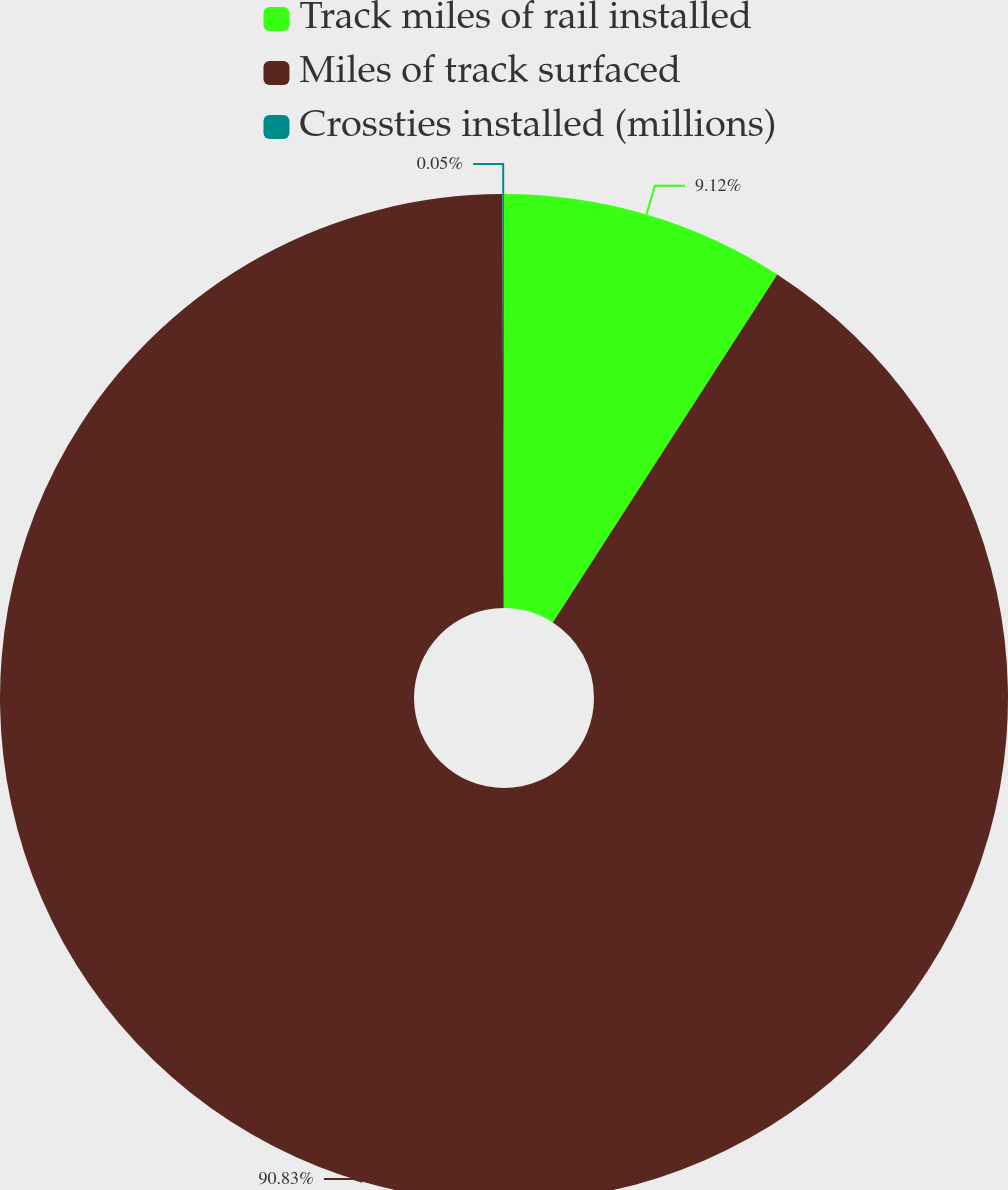Convert chart to OTSL. <chart><loc_0><loc_0><loc_500><loc_500><pie_chart><fcel>Track miles of rail installed<fcel>Miles of track surfaced<fcel>Crossties installed (millions)<nl><fcel>9.12%<fcel>90.83%<fcel>0.05%<nl></chart> 